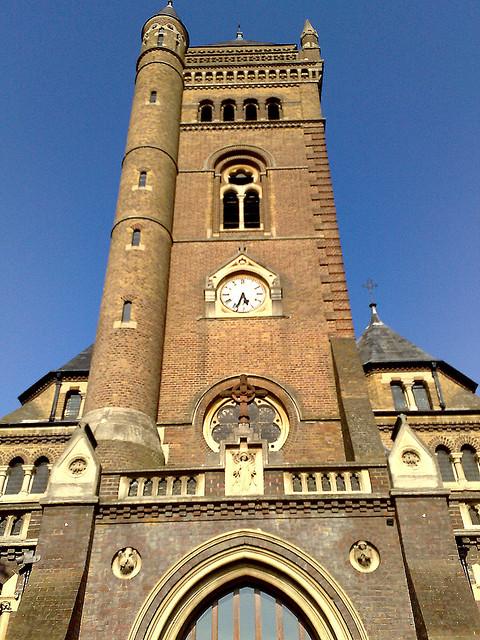Is this tower for an elevator?
Give a very brief answer. No. Is this a skyscraper?
Keep it brief. No. How many cylindrical towers?
Answer briefly. 1. 